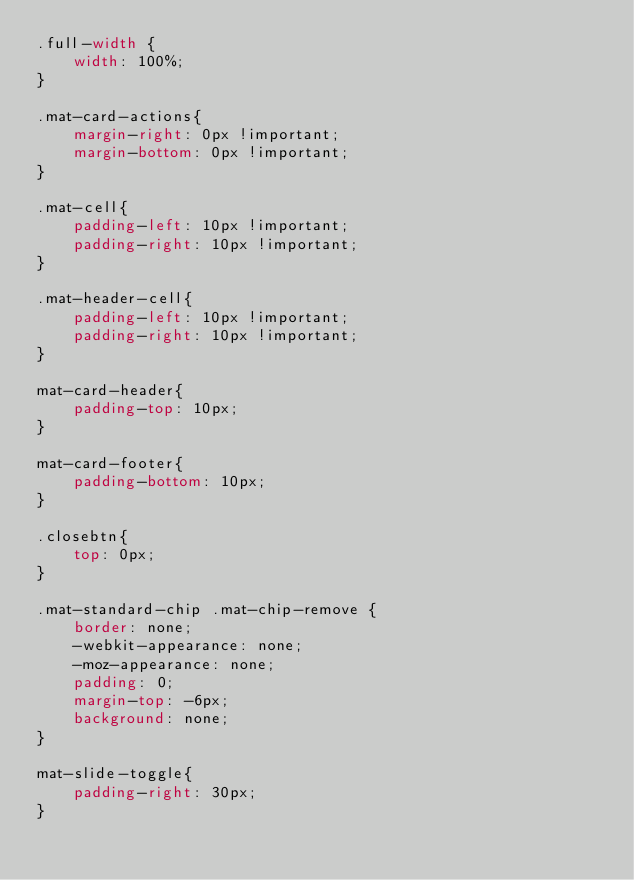Convert code to text. <code><loc_0><loc_0><loc_500><loc_500><_CSS_>.full-width {
    width: 100%;
}

.mat-card-actions{
    margin-right: 0px !important;
    margin-bottom: 0px !important;
}

.mat-cell{
    padding-left: 10px !important;
    padding-right: 10px !important;
}

.mat-header-cell{
    padding-left: 10px !important;
    padding-right: 10px !important;
}

mat-card-header{
    padding-top: 10px;
}

mat-card-footer{
    padding-bottom: 10px;
}

.closebtn{
    top: 0px;
}

.mat-standard-chip .mat-chip-remove {
    border: none;
    -webkit-appearance: none;
    -moz-appearance: none;
    padding: 0;
    margin-top: -6px;
    background: none;
}

mat-slide-toggle{
    padding-right: 30px;
}</code> 